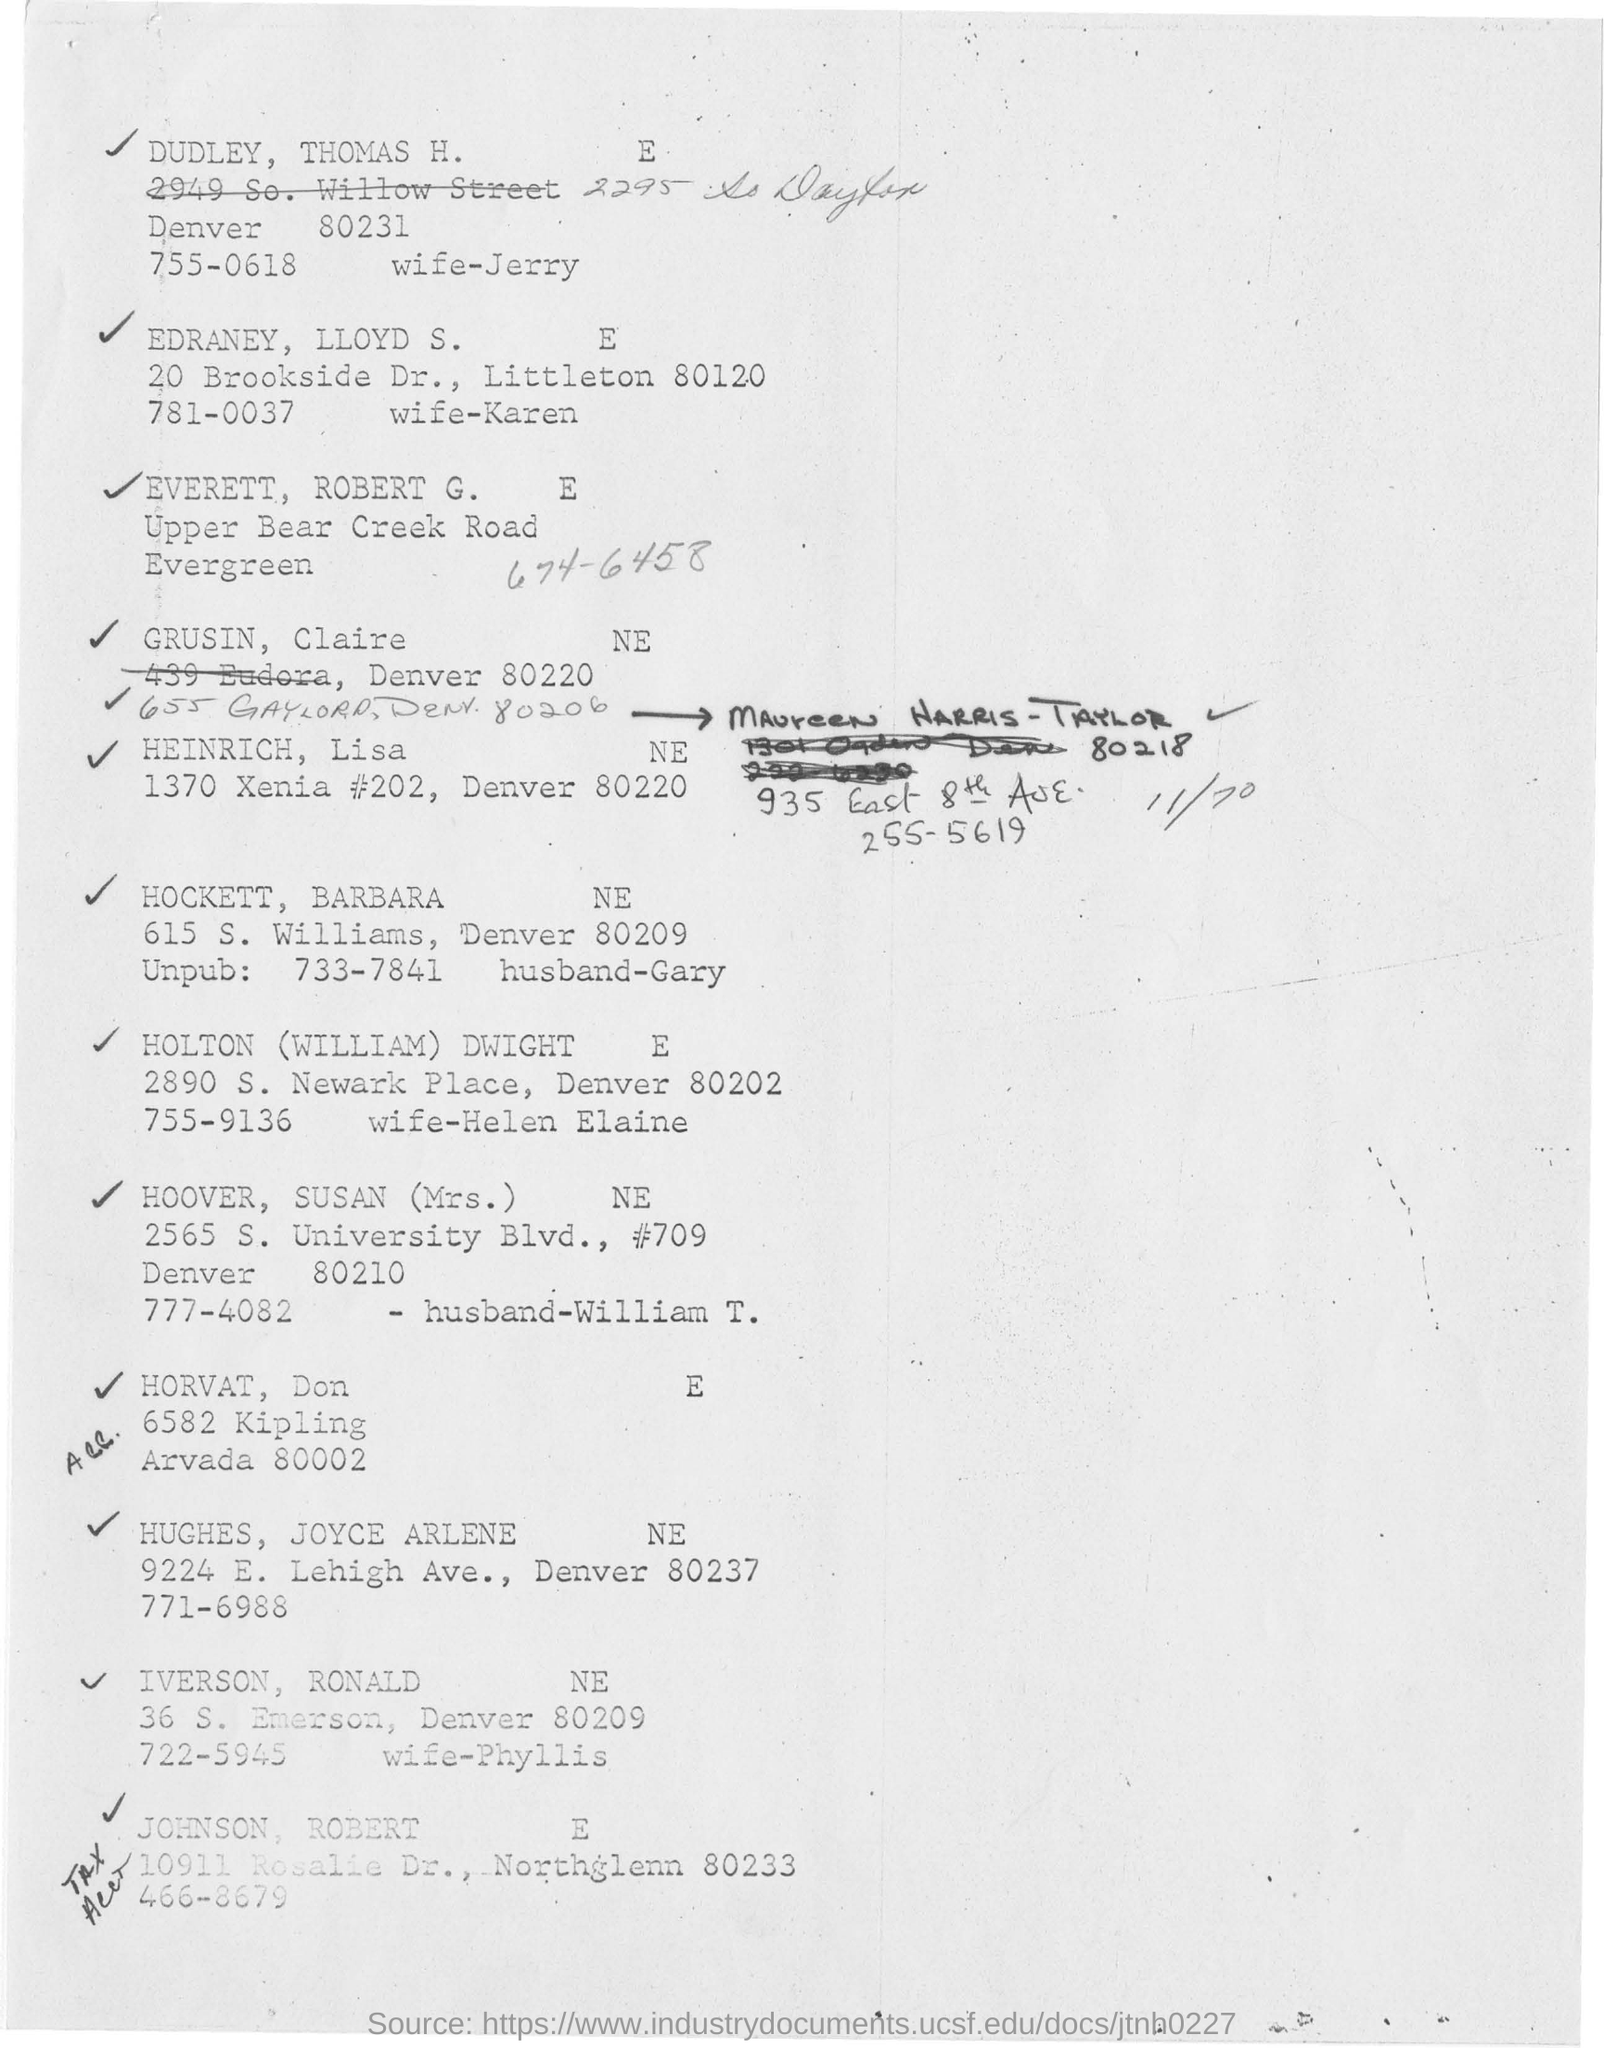Outline some significant characteristics in this image. It is known that Phyllis is the wife of Iverson, Ronald, who is a resident of New England. The husband of Mrs. Hoover, Susan, is named William T. The husband of Jerry is named Dudley, and his name is Thomas H.\* The address of HEINRICH, lisa, is located in NE and is located at 1370 Xenia #202, Denver 80220. 